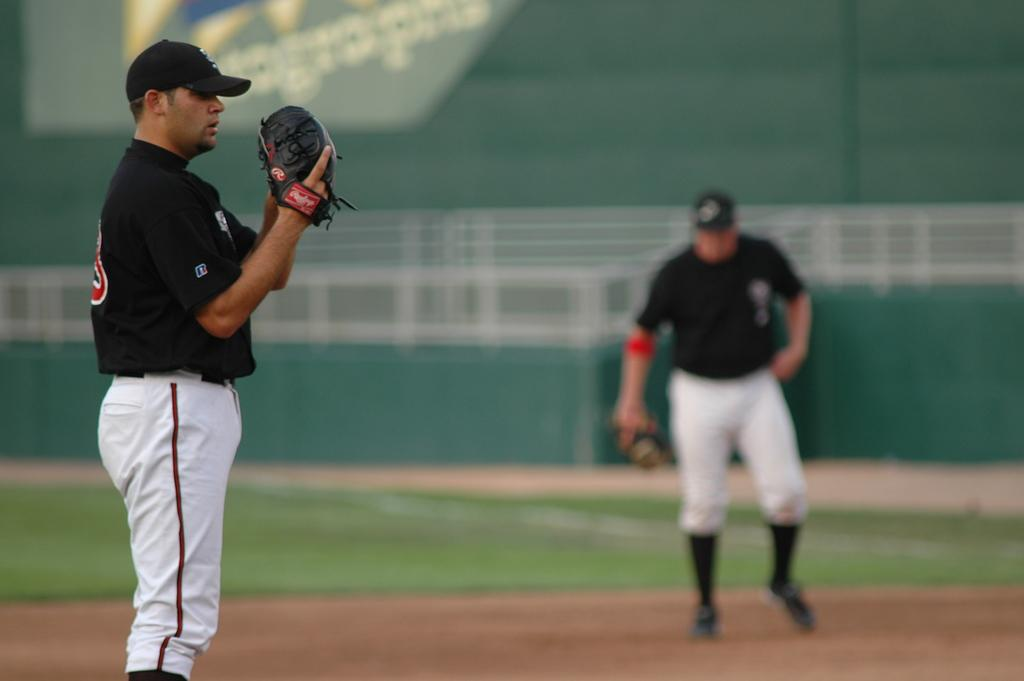How many people are present in the image? There are two people standing on the ground in the image. What is one of the people holding in his hand? One of the people is holding an object in his hand. What can be seen behind the people in the image? There is a banner with a logo and some text behind the people. What is the texture of the wax in the image? There is no wax present in the image. 